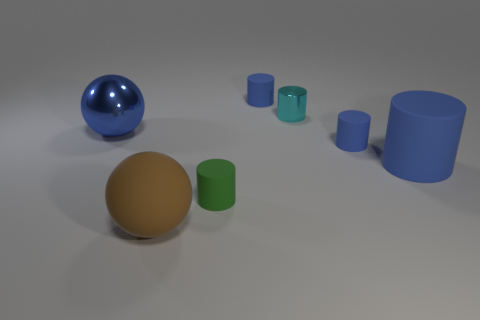What can you tell me about the textures and colors seen in this arrangement? The image showcases an assortment of smooth-looking 3D objects with matte and metallic surfaces. The color palette consists of a cool hue spectrum with cyan, blue, and green colors, except for one object that stands out with a warm, brown tone. The textures and reflections suggest a simulation or a digitally-rendered scene. 